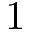<formula> <loc_0><loc_0><loc_500><loc_500>1</formula> 